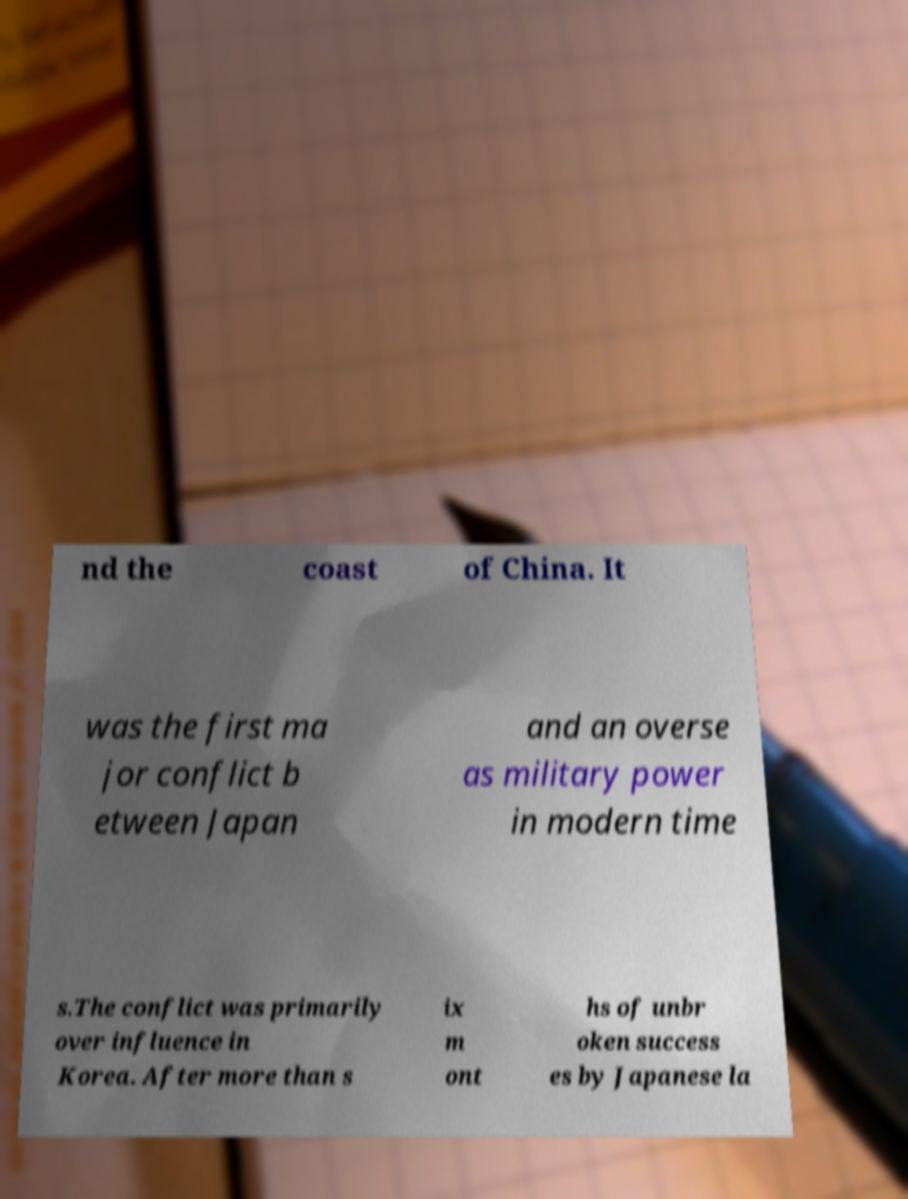I need the written content from this picture converted into text. Can you do that? nd the coast of China. It was the first ma jor conflict b etween Japan and an overse as military power in modern time s.The conflict was primarily over influence in Korea. After more than s ix m ont hs of unbr oken success es by Japanese la 